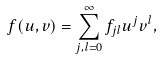Convert formula to latex. <formula><loc_0><loc_0><loc_500><loc_500>f ( u , v ) = \sum _ { j , l = 0 } ^ { \infty } f _ { j l } u ^ { j } v ^ { l } ,</formula> 